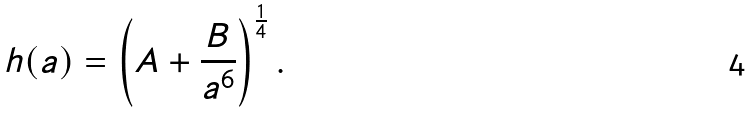<formula> <loc_0><loc_0><loc_500><loc_500>h ( a ) = \left ( A + \frac { B } { a ^ { 6 } } \right ) ^ { \frac { 1 } { 4 } } .</formula> 